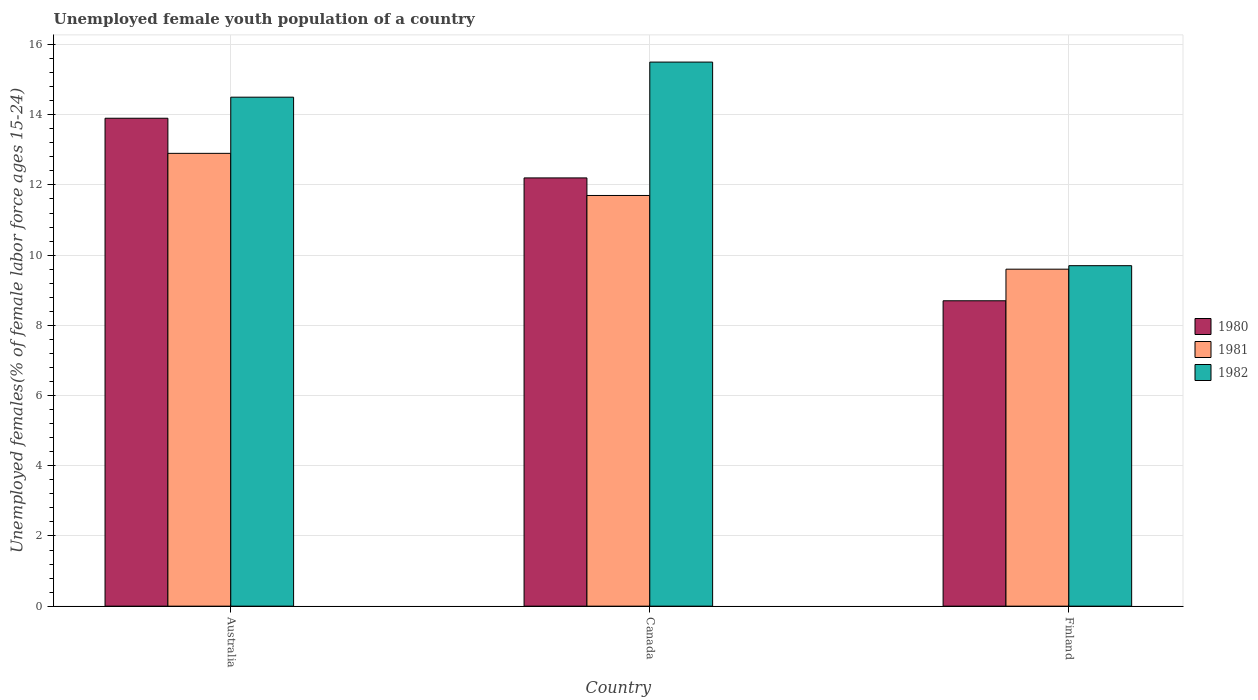How many different coloured bars are there?
Your answer should be compact. 3. How many groups of bars are there?
Provide a short and direct response. 3. Are the number of bars per tick equal to the number of legend labels?
Your answer should be compact. Yes. In how many cases, is the number of bars for a given country not equal to the number of legend labels?
Ensure brevity in your answer.  0. What is the percentage of unemployed female youth population in 1982 in Finland?
Offer a terse response. 9.7. Across all countries, what is the maximum percentage of unemployed female youth population in 1980?
Make the answer very short. 13.9. Across all countries, what is the minimum percentage of unemployed female youth population in 1982?
Provide a short and direct response. 9.7. In which country was the percentage of unemployed female youth population in 1980 maximum?
Provide a short and direct response. Australia. What is the total percentage of unemployed female youth population in 1982 in the graph?
Provide a short and direct response. 39.7. What is the difference between the percentage of unemployed female youth population in 1980 in Australia and that in Canada?
Give a very brief answer. 1.7. What is the difference between the percentage of unemployed female youth population in 1982 in Finland and the percentage of unemployed female youth population in 1980 in Australia?
Offer a very short reply. -4.2. What is the average percentage of unemployed female youth population in 1981 per country?
Keep it short and to the point. 11.4. What is the difference between the percentage of unemployed female youth population of/in 1981 and percentage of unemployed female youth population of/in 1982 in Finland?
Ensure brevity in your answer.  -0.1. What is the ratio of the percentage of unemployed female youth population in 1981 in Australia to that in Canada?
Provide a succinct answer. 1.1. Is the percentage of unemployed female youth population in 1980 in Australia less than that in Finland?
Keep it short and to the point. No. What is the difference between the highest and the second highest percentage of unemployed female youth population in 1981?
Offer a terse response. -2.1. What is the difference between the highest and the lowest percentage of unemployed female youth population in 1981?
Provide a short and direct response. 3.3. Is the sum of the percentage of unemployed female youth population in 1980 in Canada and Finland greater than the maximum percentage of unemployed female youth population in 1981 across all countries?
Provide a succinct answer. Yes. What does the 3rd bar from the right in Australia represents?
Offer a terse response. 1980. How many bars are there?
Ensure brevity in your answer.  9. Are all the bars in the graph horizontal?
Give a very brief answer. No. Are the values on the major ticks of Y-axis written in scientific E-notation?
Offer a very short reply. No. Does the graph contain grids?
Offer a terse response. Yes. Where does the legend appear in the graph?
Your answer should be very brief. Center right. How are the legend labels stacked?
Provide a succinct answer. Vertical. What is the title of the graph?
Provide a succinct answer. Unemployed female youth population of a country. What is the label or title of the X-axis?
Ensure brevity in your answer.  Country. What is the label or title of the Y-axis?
Keep it short and to the point. Unemployed females(% of female labor force ages 15-24). What is the Unemployed females(% of female labor force ages 15-24) of 1980 in Australia?
Provide a short and direct response. 13.9. What is the Unemployed females(% of female labor force ages 15-24) in 1981 in Australia?
Your answer should be very brief. 12.9. What is the Unemployed females(% of female labor force ages 15-24) in 1982 in Australia?
Give a very brief answer. 14.5. What is the Unemployed females(% of female labor force ages 15-24) of 1980 in Canada?
Offer a terse response. 12.2. What is the Unemployed females(% of female labor force ages 15-24) in 1981 in Canada?
Your answer should be very brief. 11.7. What is the Unemployed females(% of female labor force ages 15-24) in 1982 in Canada?
Your answer should be compact. 15.5. What is the Unemployed females(% of female labor force ages 15-24) in 1980 in Finland?
Your response must be concise. 8.7. What is the Unemployed females(% of female labor force ages 15-24) in 1981 in Finland?
Your answer should be compact. 9.6. What is the Unemployed females(% of female labor force ages 15-24) of 1982 in Finland?
Your response must be concise. 9.7. Across all countries, what is the maximum Unemployed females(% of female labor force ages 15-24) of 1980?
Make the answer very short. 13.9. Across all countries, what is the maximum Unemployed females(% of female labor force ages 15-24) in 1981?
Offer a terse response. 12.9. Across all countries, what is the minimum Unemployed females(% of female labor force ages 15-24) in 1980?
Offer a very short reply. 8.7. Across all countries, what is the minimum Unemployed females(% of female labor force ages 15-24) in 1981?
Make the answer very short. 9.6. Across all countries, what is the minimum Unemployed females(% of female labor force ages 15-24) of 1982?
Your answer should be compact. 9.7. What is the total Unemployed females(% of female labor force ages 15-24) of 1980 in the graph?
Keep it short and to the point. 34.8. What is the total Unemployed females(% of female labor force ages 15-24) of 1981 in the graph?
Make the answer very short. 34.2. What is the total Unemployed females(% of female labor force ages 15-24) of 1982 in the graph?
Give a very brief answer. 39.7. What is the difference between the Unemployed females(% of female labor force ages 15-24) in 1980 in Australia and that in Canada?
Make the answer very short. 1.7. What is the difference between the Unemployed females(% of female labor force ages 15-24) in 1981 in Australia and that in Canada?
Offer a very short reply. 1.2. What is the difference between the Unemployed females(% of female labor force ages 15-24) in 1982 in Australia and that in Canada?
Provide a succinct answer. -1. What is the difference between the Unemployed females(% of female labor force ages 15-24) of 1982 in Australia and that in Finland?
Keep it short and to the point. 4.8. What is the difference between the Unemployed females(% of female labor force ages 15-24) in 1981 in Canada and that in Finland?
Provide a short and direct response. 2.1. What is the difference between the Unemployed females(% of female labor force ages 15-24) in 1982 in Canada and that in Finland?
Your response must be concise. 5.8. What is the difference between the Unemployed females(% of female labor force ages 15-24) in 1980 in Canada and the Unemployed females(% of female labor force ages 15-24) in 1982 in Finland?
Offer a terse response. 2.5. What is the average Unemployed females(% of female labor force ages 15-24) in 1982 per country?
Your response must be concise. 13.23. What is the difference between the Unemployed females(% of female labor force ages 15-24) in 1980 and Unemployed females(% of female labor force ages 15-24) in 1981 in Australia?
Offer a terse response. 1. What is the difference between the Unemployed females(% of female labor force ages 15-24) of 1981 and Unemployed females(% of female labor force ages 15-24) of 1982 in Australia?
Ensure brevity in your answer.  -1.6. What is the difference between the Unemployed females(% of female labor force ages 15-24) of 1980 and Unemployed females(% of female labor force ages 15-24) of 1981 in Canada?
Give a very brief answer. 0.5. What is the difference between the Unemployed females(% of female labor force ages 15-24) in 1980 and Unemployed females(% of female labor force ages 15-24) in 1982 in Canada?
Offer a terse response. -3.3. What is the difference between the Unemployed females(% of female labor force ages 15-24) in 1980 and Unemployed females(% of female labor force ages 15-24) in 1982 in Finland?
Offer a terse response. -1. What is the difference between the Unemployed females(% of female labor force ages 15-24) in 1981 and Unemployed females(% of female labor force ages 15-24) in 1982 in Finland?
Make the answer very short. -0.1. What is the ratio of the Unemployed females(% of female labor force ages 15-24) in 1980 in Australia to that in Canada?
Your answer should be very brief. 1.14. What is the ratio of the Unemployed females(% of female labor force ages 15-24) in 1981 in Australia to that in Canada?
Provide a succinct answer. 1.1. What is the ratio of the Unemployed females(% of female labor force ages 15-24) of 1982 in Australia to that in Canada?
Your answer should be compact. 0.94. What is the ratio of the Unemployed females(% of female labor force ages 15-24) of 1980 in Australia to that in Finland?
Give a very brief answer. 1.6. What is the ratio of the Unemployed females(% of female labor force ages 15-24) in 1981 in Australia to that in Finland?
Ensure brevity in your answer.  1.34. What is the ratio of the Unemployed females(% of female labor force ages 15-24) of 1982 in Australia to that in Finland?
Give a very brief answer. 1.49. What is the ratio of the Unemployed females(% of female labor force ages 15-24) in 1980 in Canada to that in Finland?
Ensure brevity in your answer.  1.4. What is the ratio of the Unemployed females(% of female labor force ages 15-24) in 1981 in Canada to that in Finland?
Provide a short and direct response. 1.22. What is the ratio of the Unemployed females(% of female labor force ages 15-24) of 1982 in Canada to that in Finland?
Give a very brief answer. 1.6. What is the difference between the highest and the second highest Unemployed females(% of female labor force ages 15-24) in 1980?
Provide a short and direct response. 1.7. What is the difference between the highest and the second highest Unemployed females(% of female labor force ages 15-24) in 1981?
Your answer should be compact. 1.2. What is the difference between the highest and the lowest Unemployed females(% of female labor force ages 15-24) in 1980?
Your answer should be very brief. 5.2. 